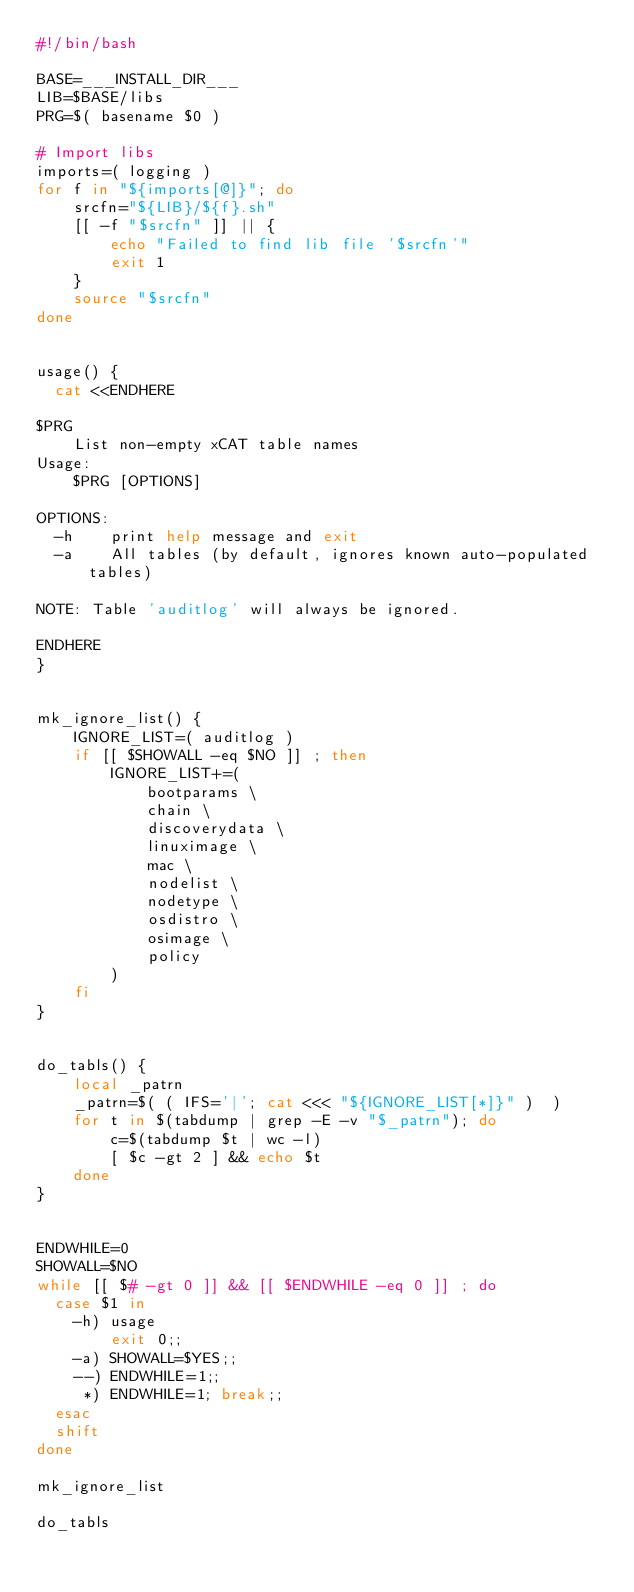<code> <loc_0><loc_0><loc_500><loc_500><_Bash_>#!/bin/bash

BASE=___INSTALL_DIR___
LIB=$BASE/libs
PRG=$( basename $0 )

# Import libs
imports=( logging )
for f in "${imports[@]}"; do
    srcfn="${LIB}/${f}.sh"
    [[ -f "$srcfn" ]] || {
        echo "Failed to find lib file '$srcfn'"
        exit 1
    }
    source "$srcfn"
done


usage() {
  cat <<ENDHERE

$PRG
    List non-empty xCAT table names
Usage:
    $PRG [OPTIONS]

OPTIONS:
  -h    print help message and exit
  -a    All tables (by default, ignores known auto-populated tables)

NOTE: Table 'auditlog' will always be ignored.

ENDHERE
}


mk_ignore_list() {
    IGNORE_LIST=( auditlog )
    if [[ $SHOWALL -eq $NO ]] ; then
        IGNORE_LIST+=( 
            bootparams \
            chain \
            discoverydata \
            linuximage \
            mac \
            nodelist \
            nodetype \
            osdistro \
            osimage \
            policy
        )
    fi
}


do_tabls() {
    local _patrn
    _patrn=$( ( IFS='|'; cat <<< "${IGNORE_LIST[*]}" )  )
    for t in $(tabdump | grep -E -v "$_patrn"); do
        c=$(tabdump $t | wc -l)
        [ $c -gt 2 ] && echo $t
    done
}


ENDWHILE=0
SHOWALL=$NO
while [[ $# -gt 0 ]] && [[ $ENDWHILE -eq 0 ]] ; do
  case $1 in
    -h) usage
        exit 0;;
    -a) SHOWALL=$YES;;
    --) ENDWHILE=1;;
     *) ENDWHILE=1; break;;
  esac
  shift
done

mk_ignore_list

do_tabls
</code> 